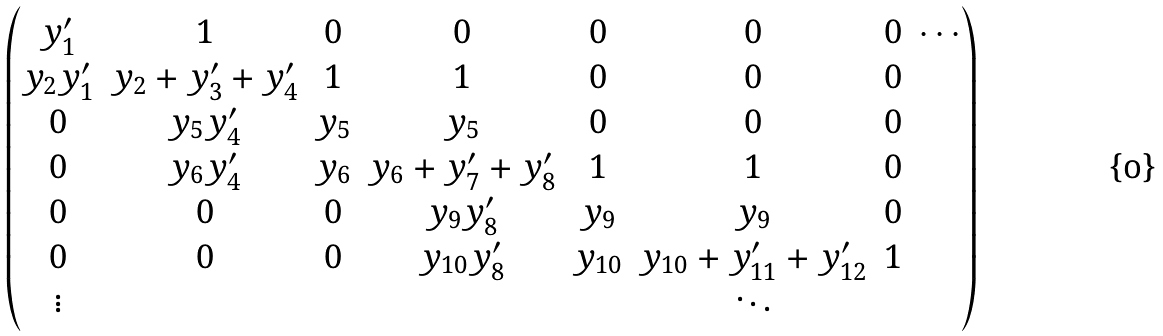Convert formula to latex. <formula><loc_0><loc_0><loc_500><loc_500>\begin{pmatrix} y _ { 1 } ^ { \prime } & 1 & 0 & 0 & 0 & 0 & 0 & \cdots \\ y _ { 2 } y _ { 1 } ^ { \prime } & y _ { 2 } + y _ { 3 } ^ { \prime } + y _ { 4 } ^ { \prime } & 1 & 1 & 0 & 0 & 0 & \\ 0 & y _ { 5 } y _ { 4 } ^ { \prime } & y _ { 5 } & y _ { 5 } & 0 & 0 & 0 & \\ 0 & y _ { 6 } y _ { 4 } ^ { \prime } & y _ { 6 } & y _ { 6 } + y _ { 7 } ^ { \prime } + y _ { 8 } ^ { \prime } & 1 & 1 & 0 & \\ 0 & 0 & 0 & y _ { 9 } y _ { 8 } ^ { \prime } & y _ { 9 } & y _ { 9 } & 0 & \\ 0 & 0 & 0 & y _ { 1 0 } y _ { 8 } ^ { \prime } & y _ { 1 0 } & y _ { 1 0 } + y _ { 1 1 } ^ { \prime } + y _ { 1 2 } ^ { \prime } & 1 & \\ \vdots & & & & & \ddots & & \\ \end{pmatrix}</formula> 